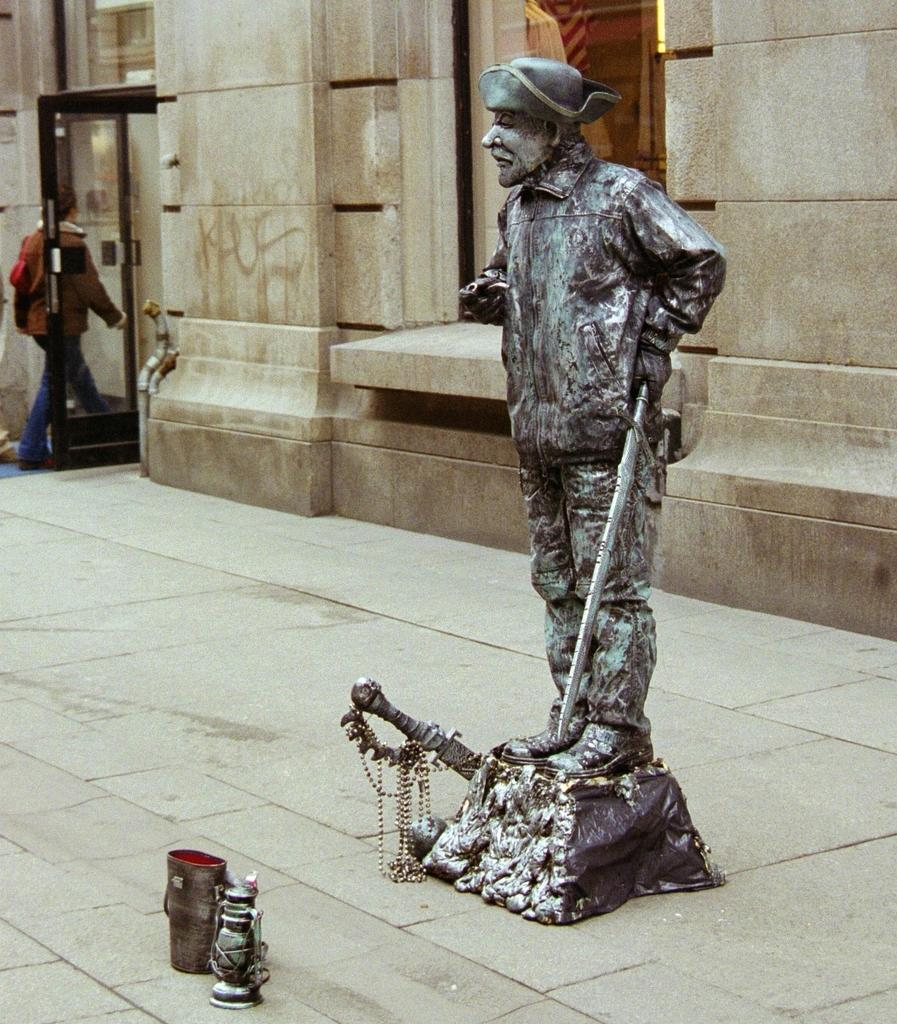What type of structure is visible in the image? There is a building in the image. What is the man in the image doing? There is a man walking in the image. What is the statue made of in the image? The statue is in the image, but the material it is made of is not specified. What is on the ground near the building in the image? There are articles on the sidewalk in the image. What type of lip balm is the man applying in the image? There is no lip balm or any indication of the man applying anything in the image. What things are the man stretching in the image? There is no mention of the man stretching or any objects being stretched in the image. 